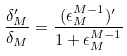Convert formula to latex. <formula><loc_0><loc_0><loc_500><loc_500>\frac { \delta _ { M } ^ { \prime } } { \delta _ { M } } = \frac { ( \epsilon _ { M } ^ { M - 1 } ) ^ { \prime } } { 1 + \epsilon _ { M } ^ { M - 1 } }</formula> 